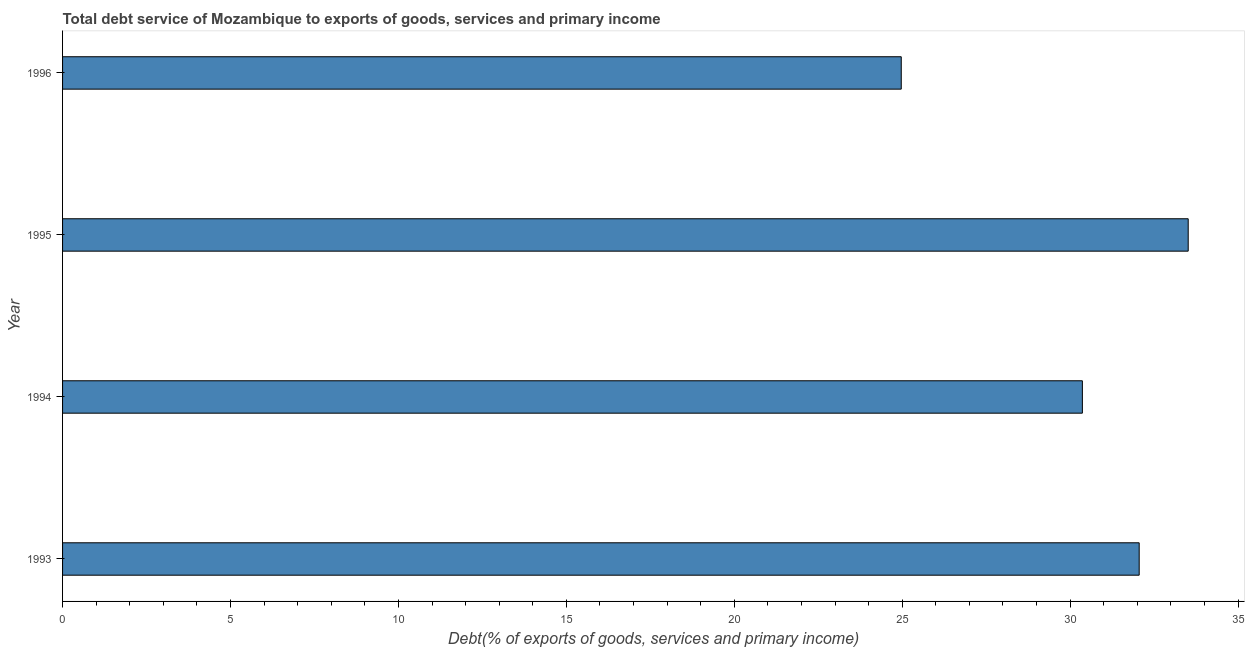What is the title of the graph?
Offer a terse response. Total debt service of Mozambique to exports of goods, services and primary income. What is the label or title of the X-axis?
Ensure brevity in your answer.  Debt(% of exports of goods, services and primary income). What is the label or title of the Y-axis?
Your response must be concise. Year. What is the total debt service in 1994?
Your answer should be compact. 30.36. Across all years, what is the maximum total debt service?
Your answer should be very brief. 33.51. Across all years, what is the minimum total debt service?
Give a very brief answer. 24.97. In which year was the total debt service maximum?
Offer a terse response. 1995. In which year was the total debt service minimum?
Your answer should be very brief. 1996. What is the sum of the total debt service?
Your response must be concise. 120.9. What is the difference between the total debt service in 1993 and 1996?
Your response must be concise. 7.08. What is the average total debt service per year?
Your answer should be compact. 30.23. What is the median total debt service?
Provide a succinct answer. 31.21. Do a majority of the years between 1993 and 1994 (inclusive) have total debt service greater than 29 %?
Your answer should be compact. Yes. What is the ratio of the total debt service in 1994 to that in 1995?
Your answer should be compact. 0.91. What is the difference between the highest and the second highest total debt service?
Your answer should be compact. 1.46. What is the difference between the highest and the lowest total debt service?
Your answer should be compact. 8.54. How many bars are there?
Make the answer very short. 4. Are all the bars in the graph horizontal?
Make the answer very short. Yes. Are the values on the major ticks of X-axis written in scientific E-notation?
Make the answer very short. No. What is the Debt(% of exports of goods, services and primary income) in 1993?
Keep it short and to the point. 32.05. What is the Debt(% of exports of goods, services and primary income) in 1994?
Provide a short and direct response. 30.36. What is the Debt(% of exports of goods, services and primary income) of 1995?
Give a very brief answer. 33.51. What is the Debt(% of exports of goods, services and primary income) in 1996?
Make the answer very short. 24.97. What is the difference between the Debt(% of exports of goods, services and primary income) in 1993 and 1994?
Provide a short and direct response. 1.69. What is the difference between the Debt(% of exports of goods, services and primary income) in 1993 and 1995?
Provide a succinct answer. -1.46. What is the difference between the Debt(% of exports of goods, services and primary income) in 1993 and 1996?
Give a very brief answer. 7.08. What is the difference between the Debt(% of exports of goods, services and primary income) in 1994 and 1995?
Provide a succinct answer. -3.15. What is the difference between the Debt(% of exports of goods, services and primary income) in 1994 and 1996?
Offer a terse response. 5.39. What is the difference between the Debt(% of exports of goods, services and primary income) in 1995 and 1996?
Your answer should be compact. 8.54. What is the ratio of the Debt(% of exports of goods, services and primary income) in 1993 to that in 1994?
Provide a succinct answer. 1.06. What is the ratio of the Debt(% of exports of goods, services and primary income) in 1993 to that in 1995?
Ensure brevity in your answer.  0.96. What is the ratio of the Debt(% of exports of goods, services and primary income) in 1993 to that in 1996?
Ensure brevity in your answer.  1.28. What is the ratio of the Debt(% of exports of goods, services and primary income) in 1994 to that in 1995?
Make the answer very short. 0.91. What is the ratio of the Debt(% of exports of goods, services and primary income) in 1994 to that in 1996?
Offer a terse response. 1.22. What is the ratio of the Debt(% of exports of goods, services and primary income) in 1995 to that in 1996?
Provide a succinct answer. 1.34. 